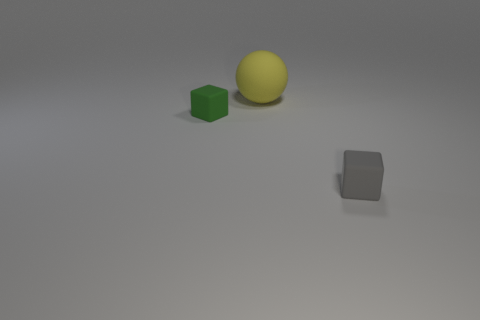Add 3 large blue shiny cubes. How many objects exist? 6 Subtract all spheres. How many objects are left? 2 Subtract 0 cyan cylinders. How many objects are left? 3 Subtract all small green blocks. Subtract all cubes. How many objects are left? 0 Add 1 tiny matte things. How many tiny matte things are left? 3 Add 1 big blue matte cylinders. How many big blue matte cylinders exist? 1 